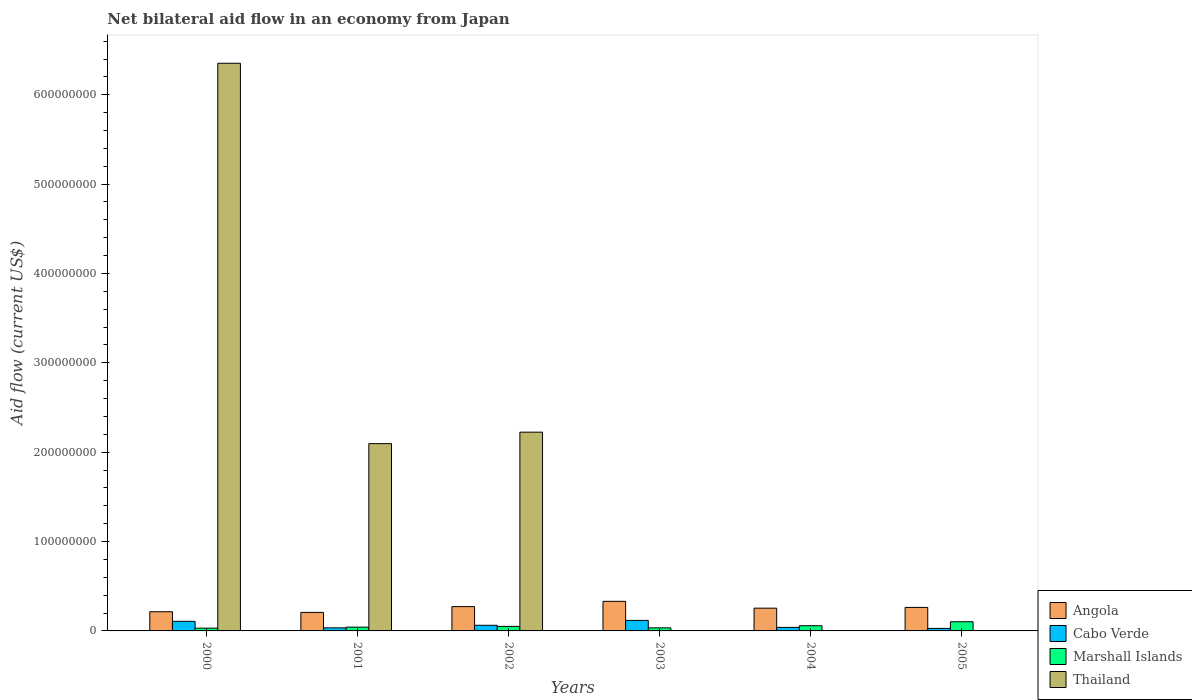How many different coloured bars are there?
Give a very brief answer. 4. How many groups of bars are there?
Give a very brief answer. 6. Are the number of bars per tick equal to the number of legend labels?
Ensure brevity in your answer.  No. How many bars are there on the 5th tick from the right?
Your response must be concise. 4. What is the label of the 6th group of bars from the left?
Make the answer very short. 2005. What is the net bilateral aid flow in Thailand in 2004?
Your answer should be very brief. 0. Across all years, what is the maximum net bilateral aid flow in Thailand?
Your response must be concise. 6.35e+08. Across all years, what is the minimum net bilateral aid flow in Marshall Islands?
Make the answer very short. 3.11e+06. What is the total net bilateral aid flow in Cabo Verde in the graph?
Ensure brevity in your answer.  3.90e+07. What is the difference between the net bilateral aid flow in Cabo Verde in 2003 and that in 2005?
Your answer should be compact. 8.94e+06. What is the difference between the net bilateral aid flow in Angola in 2001 and the net bilateral aid flow in Cabo Verde in 2004?
Your response must be concise. 1.68e+07. What is the average net bilateral aid flow in Cabo Verde per year?
Your response must be concise. 6.50e+06. In the year 2000, what is the difference between the net bilateral aid flow in Angola and net bilateral aid flow in Cabo Verde?
Your answer should be compact. 1.07e+07. In how many years, is the net bilateral aid flow in Angola greater than 320000000 US$?
Provide a short and direct response. 0. What is the ratio of the net bilateral aid flow in Marshall Islands in 2001 to that in 2005?
Ensure brevity in your answer.  0.41. Is the difference between the net bilateral aid flow in Angola in 2001 and 2004 greater than the difference between the net bilateral aid flow in Cabo Verde in 2001 and 2004?
Provide a succinct answer. No. What is the difference between the highest and the second highest net bilateral aid flow in Angola?
Your answer should be very brief. 5.89e+06. What is the difference between the highest and the lowest net bilateral aid flow in Cabo Verde?
Keep it short and to the point. 8.94e+06. Is it the case that in every year, the sum of the net bilateral aid flow in Angola and net bilateral aid flow in Cabo Verde is greater than the net bilateral aid flow in Marshall Islands?
Give a very brief answer. Yes. How many bars are there?
Provide a short and direct response. 21. Are all the bars in the graph horizontal?
Your answer should be compact. No. What is the difference between two consecutive major ticks on the Y-axis?
Offer a terse response. 1.00e+08. Are the values on the major ticks of Y-axis written in scientific E-notation?
Make the answer very short. No. Does the graph contain any zero values?
Provide a succinct answer. Yes. Does the graph contain grids?
Give a very brief answer. No. How many legend labels are there?
Provide a succinct answer. 4. What is the title of the graph?
Your answer should be compact. Net bilateral aid flow in an economy from Japan. Does "Liechtenstein" appear as one of the legend labels in the graph?
Ensure brevity in your answer.  No. What is the label or title of the X-axis?
Ensure brevity in your answer.  Years. What is the label or title of the Y-axis?
Keep it short and to the point. Aid flow (current US$). What is the Aid flow (current US$) of Angola in 2000?
Your response must be concise. 2.15e+07. What is the Aid flow (current US$) of Cabo Verde in 2000?
Offer a very short reply. 1.07e+07. What is the Aid flow (current US$) of Marshall Islands in 2000?
Give a very brief answer. 3.11e+06. What is the Aid flow (current US$) of Thailand in 2000?
Ensure brevity in your answer.  6.35e+08. What is the Aid flow (current US$) in Angola in 2001?
Keep it short and to the point. 2.07e+07. What is the Aid flow (current US$) of Cabo Verde in 2001?
Ensure brevity in your answer.  3.43e+06. What is the Aid flow (current US$) in Marshall Islands in 2001?
Your answer should be compact. 4.21e+06. What is the Aid flow (current US$) in Thailand in 2001?
Make the answer very short. 2.10e+08. What is the Aid flow (current US$) in Angola in 2002?
Make the answer very short. 2.72e+07. What is the Aid flow (current US$) of Cabo Verde in 2002?
Keep it short and to the point. 6.31e+06. What is the Aid flow (current US$) in Marshall Islands in 2002?
Provide a short and direct response. 5.07e+06. What is the Aid flow (current US$) of Thailand in 2002?
Provide a succinct answer. 2.22e+08. What is the Aid flow (current US$) of Angola in 2003?
Ensure brevity in your answer.  3.31e+07. What is the Aid flow (current US$) in Cabo Verde in 2003?
Offer a terse response. 1.18e+07. What is the Aid flow (current US$) in Marshall Islands in 2003?
Your answer should be compact. 3.44e+06. What is the Aid flow (current US$) of Angola in 2004?
Provide a succinct answer. 2.55e+07. What is the Aid flow (current US$) in Cabo Verde in 2004?
Keep it short and to the point. 3.94e+06. What is the Aid flow (current US$) in Marshall Islands in 2004?
Your answer should be compact. 5.80e+06. What is the Aid flow (current US$) of Thailand in 2004?
Your response must be concise. 0. What is the Aid flow (current US$) in Angola in 2005?
Your answer should be very brief. 2.63e+07. What is the Aid flow (current US$) in Cabo Verde in 2005?
Give a very brief answer. 2.83e+06. What is the Aid flow (current US$) of Marshall Islands in 2005?
Offer a very short reply. 1.03e+07. Across all years, what is the maximum Aid flow (current US$) in Angola?
Offer a very short reply. 3.31e+07. Across all years, what is the maximum Aid flow (current US$) in Cabo Verde?
Give a very brief answer. 1.18e+07. Across all years, what is the maximum Aid flow (current US$) in Marshall Islands?
Your answer should be very brief. 1.03e+07. Across all years, what is the maximum Aid flow (current US$) in Thailand?
Keep it short and to the point. 6.35e+08. Across all years, what is the minimum Aid flow (current US$) of Angola?
Your answer should be very brief. 2.07e+07. Across all years, what is the minimum Aid flow (current US$) in Cabo Verde?
Your answer should be very brief. 2.83e+06. Across all years, what is the minimum Aid flow (current US$) in Marshall Islands?
Give a very brief answer. 3.11e+06. What is the total Aid flow (current US$) of Angola in the graph?
Your answer should be very brief. 1.54e+08. What is the total Aid flow (current US$) of Cabo Verde in the graph?
Provide a succinct answer. 3.90e+07. What is the total Aid flow (current US$) of Marshall Islands in the graph?
Provide a short and direct response. 3.19e+07. What is the total Aid flow (current US$) in Thailand in the graph?
Give a very brief answer. 1.07e+09. What is the difference between the Aid flow (current US$) in Angola in 2000 and that in 2001?
Your answer should be very brief. 7.60e+05. What is the difference between the Aid flow (current US$) of Cabo Verde in 2000 and that in 2001?
Offer a very short reply. 7.31e+06. What is the difference between the Aid flow (current US$) in Marshall Islands in 2000 and that in 2001?
Keep it short and to the point. -1.10e+06. What is the difference between the Aid flow (current US$) in Thailand in 2000 and that in 2001?
Your answer should be compact. 4.26e+08. What is the difference between the Aid flow (current US$) of Angola in 2000 and that in 2002?
Offer a very short reply. -5.74e+06. What is the difference between the Aid flow (current US$) in Cabo Verde in 2000 and that in 2002?
Your answer should be very brief. 4.43e+06. What is the difference between the Aid flow (current US$) of Marshall Islands in 2000 and that in 2002?
Offer a terse response. -1.96e+06. What is the difference between the Aid flow (current US$) in Thailand in 2000 and that in 2002?
Provide a short and direct response. 4.13e+08. What is the difference between the Aid flow (current US$) of Angola in 2000 and that in 2003?
Your answer should be compact. -1.16e+07. What is the difference between the Aid flow (current US$) of Cabo Verde in 2000 and that in 2003?
Your answer should be very brief. -1.03e+06. What is the difference between the Aid flow (current US$) in Marshall Islands in 2000 and that in 2003?
Your response must be concise. -3.30e+05. What is the difference between the Aid flow (current US$) in Angola in 2000 and that in 2004?
Offer a terse response. -4.00e+06. What is the difference between the Aid flow (current US$) in Cabo Verde in 2000 and that in 2004?
Make the answer very short. 6.80e+06. What is the difference between the Aid flow (current US$) in Marshall Islands in 2000 and that in 2004?
Your answer should be very brief. -2.69e+06. What is the difference between the Aid flow (current US$) in Angola in 2000 and that in 2005?
Provide a succinct answer. -4.83e+06. What is the difference between the Aid flow (current US$) of Cabo Verde in 2000 and that in 2005?
Provide a short and direct response. 7.91e+06. What is the difference between the Aid flow (current US$) in Marshall Islands in 2000 and that in 2005?
Your answer should be compact. -7.15e+06. What is the difference between the Aid flow (current US$) of Angola in 2001 and that in 2002?
Provide a short and direct response. -6.50e+06. What is the difference between the Aid flow (current US$) in Cabo Verde in 2001 and that in 2002?
Offer a terse response. -2.88e+06. What is the difference between the Aid flow (current US$) of Marshall Islands in 2001 and that in 2002?
Ensure brevity in your answer.  -8.60e+05. What is the difference between the Aid flow (current US$) of Thailand in 2001 and that in 2002?
Provide a succinct answer. -1.28e+07. What is the difference between the Aid flow (current US$) in Angola in 2001 and that in 2003?
Keep it short and to the point. -1.24e+07. What is the difference between the Aid flow (current US$) of Cabo Verde in 2001 and that in 2003?
Make the answer very short. -8.34e+06. What is the difference between the Aid flow (current US$) in Marshall Islands in 2001 and that in 2003?
Your answer should be very brief. 7.70e+05. What is the difference between the Aid flow (current US$) of Angola in 2001 and that in 2004?
Give a very brief answer. -4.76e+06. What is the difference between the Aid flow (current US$) of Cabo Verde in 2001 and that in 2004?
Make the answer very short. -5.10e+05. What is the difference between the Aid flow (current US$) in Marshall Islands in 2001 and that in 2004?
Your answer should be very brief. -1.59e+06. What is the difference between the Aid flow (current US$) of Angola in 2001 and that in 2005?
Give a very brief answer. -5.59e+06. What is the difference between the Aid flow (current US$) of Marshall Islands in 2001 and that in 2005?
Ensure brevity in your answer.  -6.05e+06. What is the difference between the Aid flow (current US$) of Angola in 2002 and that in 2003?
Your response must be concise. -5.89e+06. What is the difference between the Aid flow (current US$) of Cabo Verde in 2002 and that in 2003?
Make the answer very short. -5.46e+06. What is the difference between the Aid flow (current US$) in Marshall Islands in 2002 and that in 2003?
Give a very brief answer. 1.63e+06. What is the difference between the Aid flow (current US$) of Angola in 2002 and that in 2004?
Your answer should be very brief. 1.74e+06. What is the difference between the Aid flow (current US$) of Cabo Verde in 2002 and that in 2004?
Give a very brief answer. 2.37e+06. What is the difference between the Aid flow (current US$) in Marshall Islands in 2002 and that in 2004?
Offer a terse response. -7.30e+05. What is the difference between the Aid flow (current US$) of Angola in 2002 and that in 2005?
Provide a succinct answer. 9.10e+05. What is the difference between the Aid flow (current US$) of Cabo Verde in 2002 and that in 2005?
Provide a succinct answer. 3.48e+06. What is the difference between the Aid flow (current US$) in Marshall Islands in 2002 and that in 2005?
Your answer should be very brief. -5.19e+06. What is the difference between the Aid flow (current US$) in Angola in 2003 and that in 2004?
Provide a short and direct response. 7.63e+06. What is the difference between the Aid flow (current US$) of Cabo Verde in 2003 and that in 2004?
Give a very brief answer. 7.83e+06. What is the difference between the Aid flow (current US$) of Marshall Islands in 2003 and that in 2004?
Give a very brief answer. -2.36e+06. What is the difference between the Aid flow (current US$) in Angola in 2003 and that in 2005?
Provide a succinct answer. 6.80e+06. What is the difference between the Aid flow (current US$) of Cabo Verde in 2003 and that in 2005?
Make the answer very short. 8.94e+06. What is the difference between the Aid flow (current US$) in Marshall Islands in 2003 and that in 2005?
Your response must be concise. -6.82e+06. What is the difference between the Aid flow (current US$) of Angola in 2004 and that in 2005?
Make the answer very short. -8.30e+05. What is the difference between the Aid flow (current US$) in Cabo Verde in 2004 and that in 2005?
Ensure brevity in your answer.  1.11e+06. What is the difference between the Aid flow (current US$) in Marshall Islands in 2004 and that in 2005?
Provide a short and direct response. -4.46e+06. What is the difference between the Aid flow (current US$) in Angola in 2000 and the Aid flow (current US$) in Cabo Verde in 2001?
Your response must be concise. 1.80e+07. What is the difference between the Aid flow (current US$) of Angola in 2000 and the Aid flow (current US$) of Marshall Islands in 2001?
Offer a very short reply. 1.73e+07. What is the difference between the Aid flow (current US$) in Angola in 2000 and the Aid flow (current US$) in Thailand in 2001?
Ensure brevity in your answer.  -1.88e+08. What is the difference between the Aid flow (current US$) of Cabo Verde in 2000 and the Aid flow (current US$) of Marshall Islands in 2001?
Make the answer very short. 6.53e+06. What is the difference between the Aid flow (current US$) in Cabo Verde in 2000 and the Aid flow (current US$) in Thailand in 2001?
Keep it short and to the point. -1.99e+08. What is the difference between the Aid flow (current US$) in Marshall Islands in 2000 and the Aid flow (current US$) in Thailand in 2001?
Your answer should be compact. -2.06e+08. What is the difference between the Aid flow (current US$) in Angola in 2000 and the Aid flow (current US$) in Cabo Verde in 2002?
Keep it short and to the point. 1.52e+07. What is the difference between the Aid flow (current US$) in Angola in 2000 and the Aid flow (current US$) in Marshall Islands in 2002?
Offer a very short reply. 1.64e+07. What is the difference between the Aid flow (current US$) in Angola in 2000 and the Aid flow (current US$) in Thailand in 2002?
Your answer should be compact. -2.01e+08. What is the difference between the Aid flow (current US$) of Cabo Verde in 2000 and the Aid flow (current US$) of Marshall Islands in 2002?
Provide a short and direct response. 5.67e+06. What is the difference between the Aid flow (current US$) in Cabo Verde in 2000 and the Aid flow (current US$) in Thailand in 2002?
Your answer should be very brief. -2.12e+08. What is the difference between the Aid flow (current US$) of Marshall Islands in 2000 and the Aid flow (current US$) of Thailand in 2002?
Provide a succinct answer. -2.19e+08. What is the difference between the Aid flow (current US$) in Angola in 2000 and the Aid flow (current US$) in Cabo Verde in 2003?
Ensure brevity in your answer.  9.70e+06. What is the difference between the Aid flow (current US$) of Angola in 2000 and the Aid flow (current US$) of Marshall Islands in 2003?
Provide a short and direct response. 1.80e+07. What is the difference between the Aid flow (current US$) in Cabo Verde in 2000 and the Aid flow (current US$) in Marshall Islands in 2003?
Ensure brevity in your answer.  7.30e+06. What is the difference between the Aid flow (current US$) in Angola in 2000 and the Aid flow (current US$) in Cabo Verde in 2004?
Give a very brief answer. 1.75e+07. What is the difference between the Aid flow (current US$) in Angola in 2000 and the Aid flow (current US$) in Marshall Islands in 2004?
Ensure brevity in your answer.  1.57e+07. What is the difference between the Aid flow (current US$) of Cabo Verde in 2000 and the Aid flow (current US$) of Marshall Islands in 2004?
Provide a short and direct response. 4.94e+06. What is the difference between the Aid flow (current US$) in Angola in 2000 and the Aid flow (current US$) in Cabo Verde in 2005?
Offer a terse response. 1.86e+07. What is the difference between the Aid flow (current US$) in Angola in 2000 and the Aid flow (current US$) in Marshall Islands in 2005?
Your response must be concise. 1.12e+07. What is the difference between the Aid flow (current US$) of Angola in 2001 and the Aid flow (current US$) of Cabo Verde in 2002?
Ensure brevity in your answer.  1.44e+07. What is the difference between the Aid flow (current US$) in Angola in 2001 and the Aid flow (current US$) in Marshall Islands in 2002?
Keep it short and to the point. 1.56e+07. What is the difference between the Aid flow (current US$) of Angola in 2001 and the Aid flow (current US$) of Thailand in 2002?
Provide a succinct answer. -2.02e+08. What is the difference between the Aid flow (current US$) of Cabo Verde in 2001 and the Aid flow (current US$) of Marshall Islands in 2002?
Ensure brevity in your answer.  -1.64e+06. What is the difference between the Aid flow (current US$) of Cabo Verde in 2001 and the Aid flow (current US$) of Thailand in 2002?
Offer a terse response. -2.19e+08. What is the difference between the Aid flow (current US$) in Marshall Islands in 2001 and the Aid flow (current US$) in Thailand in 2002?
Offer a terse response. -2.18e+08. What is the difference between the Aid flow (current US$) of Angola in 2001 and the Aid flow (current US$) of Cabo Verde in 2003?
Make the answer very short. 8.94e+06. What is the difference between the Aid flow (current US$) in Angola in 2001 and the Aid flow (current US$) in Marshall Islands in 2003?
Make the answer very short. 1.73e+07. What is the difference between the Aid flow (current US$) of Angola in 2001 and the Aid flow (current US$) of Cabo Verde in 2004?
Give a very brief answer. 1.68e+07. What is the difference between the Aid flow (current US$) of Angola in 2001 and the Aid flow (current US$) of Marshall Islands in 2004?
Your answer should be compact. 1.49e+07. What is the difference between the Aid flow (current US$) in Cabo Verde in 2001 and the Aid flow (current US$) in Marshall Islands in 2004?
Your answer should be very brief. -2.37e+06. What is the difference between the Aid flow (current US$) of Angola in 2001 and the Aid flow (current US$) of Cabo Verde in 2005?
Make the answer very short. 1.79e+07. What is the difference between the Aid flow (current US$) of Angola in 2001 and the Aid flow (current US$) of Marshall Islands in 2005?
Your answer should be very brief. 1.04e+07. What is the difference between the Aid flow (current US$) in Cabo Verde in 2001 and the Aid flow (current US$) in Marshall Islands in 2005?
Offer a terse response. -6.83e+06. What is the difference between the Aid flow (current US$) in Angola in 2002 and the Aid flow (current US$) in Cabo Verde in 2003?
Provide a succinct answer. 1.54e+07. What is the difference between the Aid flow (current US$) of Angola in 2002 and the Aid flow (current US$) of Marshall Islands in 2003?
Keep it short and to the point. 2.38e+07. What is the difference between the Aid flow (current US$) of Cabo Verde in 2002 and the Aid flow (current US$) of Marshall Islands in 2003?
Provide a succinct answer. 2.87e+06. What is the difference between the Aid flow (current US$) of Angola in 2002 and the Aid flow (current US$) of Cabo Verde in 2004?
Ensure brevity in your answer.  2.33e+07. What is the difference between the Aid flow (current US$) in Angola in 2002 and the Aid flow (current US$) in Marshall Islands in 2004?
Ensure brevity in your answer.  2.14e+07. What is the difference between the Aid flow (current US$) in Cabo Verde in 2002 and the Aid flow (current US$) in Marshall Islands in 2004?
Offer a very short reply. 5.10e+05. What is the difference between the Aid flow (current US$) in Angola in 2002 and the Aid flow (current US$) in Cabo Verde in 2005?
Give a very brief answer. 2.44e+07. What is the difference between the Aid flow (current US$) in Angola in 2002 and the Aid flow (current US$) in Marshall Islands in 2005?
Ensure brevity in your answer.  1.70e+07. What is the difference between the Aid flow (current US$) in Cabo Verde in 2002 and the Aid flow (current US$) in Marshall Islands in 2005?
Your answer should be very brief. -3.95e+06. What is the difference between the Aid flow (current US$) of Angola in 2003 and the Aid flow (current US$) of Cabo Verde in 2004?
Your answer should be very brief. 2.92e+07. What is the difference between the Aid flow (current US$) in Angola in 2003 and the Aid flow (current US$) in Marshall Islands in 2004?
Offer a terse response. 2.73e+07. What is the difference between the Aid flow (current US$) in Cabo Verde in 2003 and the Aid flow (current US$) in Marshall Islands in 2004?
Provide a short and direct response. 5.97e+06. What is the difference between the Aid flow (current US$) of Angola in 2003 and the Aid flow (current US$) of Cabo Verde in 2005?
Keep it short and to the point. 3.03e+07. What is the difference between the Aid flow (current US$) in Angola in 2003 and the Aid flow (current US$) in Marshall Islands in 2005?
Ensure brevity in your answer.  2.28e+07. What is the difference between the Aid flow (current US$) in Cabo Verde in 2003 and the Aid flow (current US$) in Marshall Islands in 2005?
Offer a terse response. 1.51e+06. What is the difference between the Aid flow (current US$) of Angola in 2004 and the Aid flow (current US$) of Cabo Verde in 2005?
Make the answer very short. 2.26e+07. What is the difference between the Aid flow (current US$) of Angola in 2004 and the Aid flow (current US$) of Marshall Islands in 2005?
Keep it short and to the point. 1.52e+07. What is the difference between the Aid flow (current US$) in Cabo Verde in 2004 and the Aid flow (current US$) in Marshall Islands in 2005?
Provide a short and direct response. -6.32e+06. What is the average Aid flow (current US$) of Angola per year?
Ensure brevity in your answer.  2.57e+07. What is the average Aid flow (current US$) of Cabo Verde per year?
Offer a very short reply. 6.50e+06. What is the average Aid flow (current US$) of Marshall Islands per year?
Provide a succinct answer. 5.32e+06. What is the average Aid flow (current US$) in Thailand per year?
Your response must be concise. 1.78e+08. In the year 2000, what is the difference between the Aid flow (current US$) in Angola and Aid flow (current US$) in Cabo Verde?
Make the answer very short. 1.07e+07. In the year 2000, what is the difference between the Aid flow (current US$) in Angola and Aid flow (current US$) in Marshall Islands?
Your answer should be very brief. 1.84e+07. In the year 2000, what is the difference between the Aid flow (current US$) of Angola and Aid flow (current US$) of Thailand?
Give a very brief answer. -6.14e+08. In the year 2000, what is the difference between the Aid flow (current US$) of Cabo Verde and Aid flow (current US$) of Marshall Islands?
Make the answer very short. 7.63e+06. In the year 2000, what is the difference between the Aid flow (current US$) of Cabo Verde and Aid flow (current US$) of Thailand?
Ensure brevity in your answer.  -6.25e+08. In the year 2000, what is the difference between the Aid flow (current US$) of Marshall Islands and Aid flow (current US$) of Thailand?
Provide a succinct answer. -6.32e+08. In the year 2001, what is the difference between the Aid flow (current US$) of Angola and Aid flow (current US$) of Cabo Verde?
Your answer should be compact. 1.73e+07. In the year 2001, what is the difference between the Aid flow (current US$) in Angola and Aid flow (current US$) in Marshall Islands?
Your answer should be very brief. 1.65e+07. In the year 2001, what is the difference between the Aid flow (current US$) of Angola and Aid flow (current US$) of Thailand?
Your answer should be compact. -1.89e+08. In the year 2001, what is the difference between the Aid flow (current US$) in Cabo Verde and Aid flow (current US$) in Marshall Islands?
Your response must be concise. -7.80e+05. In the year 2001, what is the difference between the Aid flow (current US$) of Cabo Verde and Aid flow (current US$) of Thailand?
Your answer should be very brief. -2.06e+08. In the year 2001, what is the difference between the Aid flow (current US$) of Marshall Islands and Aid flow (current US$) of Thailand?
Keep it short and to the point. -2.05e+08. In the year 2002, what is the difference between the Aid flow (current US$) of Angola and Aid flow (current US$) of Cabo Verde?
Your answer should be very brief. 2.09e+07. In the year 2002, what is the difference between the Aid flow (current US$) in Angola and Aid flow (current US$) in Marshall Islands?
Provide a short and direct response. 2.21e+07. In the year 2002, what is the difference between the Aid flow (current US$) of Angola and Aid flow (current US$) of Thailand?
Your answer should be compact. -1.95e+08. In the year 2002, what is the difference between the Aid flow (current US$) of Cabo Verde and Aid flow (current US$) of Marshall Islands?
Provide a short and direct response. 1.24e+06. In the year 2002, what is the difference between the Aid flow (current US$) in Cabo Verde and Aid flow (current US$) in Thailand?
Provide a succinct answer. -2.16e+08. In the year 2002, what is the difference between the Aid flow (current US$) in Marshall Islands and Aid flow (current US$) in Thailand?
Offer a very short reply. -2.17e+08. In the year 2003, what is the difference between the Aid flow (current US$) of Angola and Aid flow (current US$) of Cabo Verde?
Your response must be concise. 2.13e+07. In the year 2003, what is the difference between the Aid flow (current US$) of Angola and Aid flow (current US$) of Marshall Islands?
Provide a succinct answer. 2.97e+07. In the year 2003, what is the difference between the Aid flow (current US$) of Cabo Verde and Aid flow (current US$) of Marshall Islands?
Provide a succinct answer. 8.33e+06. In the year 2004, what is the difference between the Aid flow (current US$) of Angola and Aid flow (current US$) of Cabo Verde?
Make the answer very short. 2.15e+07. In the year 2004, what is the difference between the Aid flow (current US$) of Angola and Aid flow (current US$) of Marshall Islands?
Provide a succinct answer. 1.97e+07. In the year 2004, what is the difference between the Aid flow (current US$) of Cabo Verde and Aid flow (current US$) of Marshall Islands?
Provide a short and direct response. -1.86e+06. In the year 2005, what is the difference between the Aid flow (current US$) in Angola and Aid flow (current US$) in Cabo Verde?
Your response must be concise. 2.35e+07. In the year 2005, what is the difference between the Aid flow (current US$) of Angola and Aid flow (current US$) of Marshall Islands?
Offer a very short reply. 1.60e+07. In the year 2005, what is the difference between the Aid flow (current US$) of Cabo Verde and Aid flow (current US$) of Marshall Islands?
Provide a short and direct response. -7.43e+06. What is the ratio of the Aid flow (current US$) of Angola in 2000 to that in 2001?
Offer a terse response. 1.04. What is the ratio of the Aid flow (current US$) in Cabo Verde in 2000 to that in 2001?
Ensure brevity in your answer.  3.13. What is the ratio of the Aid flow (current US$) of Marshall Islands in 2000 to that in 2001?
Offer a very short reply. 0.74. What is the ratio of the Aid flow (current US$) of Thailand in 2000 to that in 2001?
Keep it short and to the point. 3.03. What is the ratio of the Aid flow (current US$) of Angola in 2000 to that in 2002?
Keep it short and to the point. 0.79. What is the ratio of the Aid flow (current US$) in Cabo Verde in 2000 to that in 2002?
Your answer should be compact. 1.7. What is the ratio of the Aid flow (current US$) in Marshall Islands in 2000 to that in 2002?
Offer a very short reply. 0.61. What is the ratio of the Aid flow (current US$) of Thailand in 2000 to that in 2002?
Provide a succinct answer. 2.86. What is the ratio of the Aid flow (current US$) of Angola in 2000 to that in 2003?
Provide a succinct answer. 0.65. What is the ratio of the Aid flow (current US$) of Cabo Verde in 2000 to that in 2003?
Offer a terse response. 0.91. What is the ratio of the Aid flow (current US$) in Marshall Islands in 2000 to that in 2003?
Your answer should be compact. 0.9. What is the ratio of the Aid flow (current US$) in Angola in 2000 to that in 2004?
Keep it short and to the point. 0.84. What is the ratio of the Aid flow (current US$) in Cabo Verde in 2000 to that in 2004?
Make the answer very short. 2.73. What is the ratio of the Aid flow (current US$) in Marshall Islands in 2000 to that in 2004?
Make the answer very short. 0.54. What is the ratio of the Aid flow (current US$) in Angola in 2000 to that in 2005?
Offer a very short reply. 0.82. What is the ratio of the Aid flow (current US$) of Cabo Verde in 2000 to that in 2005?
Make the answer very short. 3.8. What is the ratio of the Aid flow (current US$) in Marshall Islands in 2000 to that in 2005?
Give a very brief answer. 0.3. What is the ratio of the Aid flow (current US$) in Angola in 2001 to that in 2002?
Provide a short and direct response. 0.76. What is the ratio of the Aid flow (current US$) of Cabo Verde in 2001 to that in 2002?
Ensure brevity in your answer.  0.54. What is the ratio of the Aid flow (current US$) in Marshall Islands in 2001 to that in 2002?
Provide a succinct answer. 0.83. What is the ratio of the Aid flow (current US$) of Thailand in 2001 to that in 2002?
Give a very brief answer. 0.94. What is the ratio of the Aid flow (current US$) in Angola in 2001 to that in 2003?
Your answer should be compact. 0.63. What is the ratio of the Aid flow (current US$) in Cabo Verde in 2001 to that in 2003?
Ensure brevity in your answer.  0.29. What is the ratio of the Aid flow (current US$) of Marshall Islands in 2001 to that in 2003?
Provide a short and direct response. 1.22. What is the ratio of the Aid flow (current US$) in Angola in 2001 to that in 2004?
Offer a very short reply. 0.81. What is the ratio of the Aid flow (current US$) of Cabo Verde in 2001 to that in 2004?
Ensure brevity in your answer.  0.87. What is the ratio of the Aid flow (current US$) of Marshall Islands in 2001 to that in 2004?
Ensure brevity in your answer.  0.73. What is the ratio of the Aid flow (current US$) of Angola in 2001 to that in 2005?
Your answer should be very brief. 0.79. What is the ratio of the Aid flow (current US$) in Cabo Verde in 2001 to that in 2005?
Keep it short and to the point. 1.21. What is the ratio of the Aid flow (current US$) of Marshall Islands in 2001 to that in 2005?
Keep it short and to the point. 0.41. What is the ratio of the Aid flow (current US$) in Angola in 2002 to that in 2003?
Your response must be concise. 0.82. What is the ratio of the Aid flow (current US$) in Cabo Verde in 2002 to that in 2003?
Your answer should be compact. 0.54. What is the ratio of the Aid flow (current US$) of Marshall Islands in 2002 to that in 2003?
Offer a terse response. 1.47. What is the ratio of the Aid flow (current US$) of Angola in 2002 to that in 2004?
Keep it short and to the point. 1.07. What is the ratio of the Aid flow (current US$) of Cabo Verde in 2002 to that in 2004?
Make the answer very short. 1.6. What is the ratio of the Aid flow (current US$) of Marshall Islands in 2002 to that in 2004?
Give a very brief answer. 0.87. What is the ratio of the Aid flow (current US$) in Angola in 2002 to that in 2005?
Your answer should be compact. 1.03. What is the ratio of the Aid flow (current US$) in Cabo Verde in 2002 to that in 2005?
Keep it short and to the point. 2.23. What is the ratio of the Aid flow (current US$) in Marshall Islands in 2002 to that in 2005?
Keep it short and to the point. 0.49. What is the ratio of the Aid flow (current US$) of Angola in 2003 to that in 2004?
Your answer should be very brief. 1.3. What is the ratio of the Aid flow (current US$) of Cabo Verde in 2003 to that in 2004?
Your answer should be very brief. 2.99. What is the ratio of the Aid flow (current US$) of Marshall Islands in 2003 to that in 2004?
Your answer should be compact. 0.59. What is the ratio of the Aid flow (current US$) of Angola in 2003 to that in 2005?
Ensure brevity in your answer.  1.26. What is the ratio of the Aid flow (current US$) in Cabo Verde in 2003 to that in 2005?
Your response must be concise. 4.16. What is the ratio of the Aid flow (current US$) in Marshall Islands in 2003 to that in 2005?
Provide a succinct answer. 0.34. What is the ratio of the Aid flow (current US$) in Angola in 2004 to that in 2005?
Give a very brief answer. 0.97. What is the ratio of the Aid flow (current US$) in Cabo Verde in 2004 to that in 2005?
Offer a terse response. 1.39. What is the ratio of the Aid flow (current US$) in Marshall Islands in 2004 to that in 2005?
Your answer should be very brief. 0.57. What is the difference between the highest and the second highest Aid flow (current US$) in Angola?
Your answer should be compact. 5.89e+06. What is the difference between the highest and the second highest Aid flow (current US$) in Cabo Verde?
Offer a very short reply. 1.03e+06. What is the difference between the highest and the second highest Aid flow (current US$) in Marshall Islands?
Give a very brief answer. 4.46e+06. What is the difference between the highest and the second highest Aid flow (current US$) of Thailand?
Provide a succinct answer. 4.13e+08. What is the difference between the highest and the lowest Aid flow (current US$) in Angola?
Ensure brevity in your answer.  1.24e+07. What is the difference between the highest and the lowest Aid flow (current US$) in Cabo Verde?
Your answer should be compact. 8.94e+06. What is the difference between the highest and the lowest Aid flow (current US$) in Marshall Islands?
Ensure brevity in your answer.  7.15e+06. What is the difference between the highest and the lowest Aid flow (current US$) in Thailand?
Your answer should be very brief. 6.35e+08. 